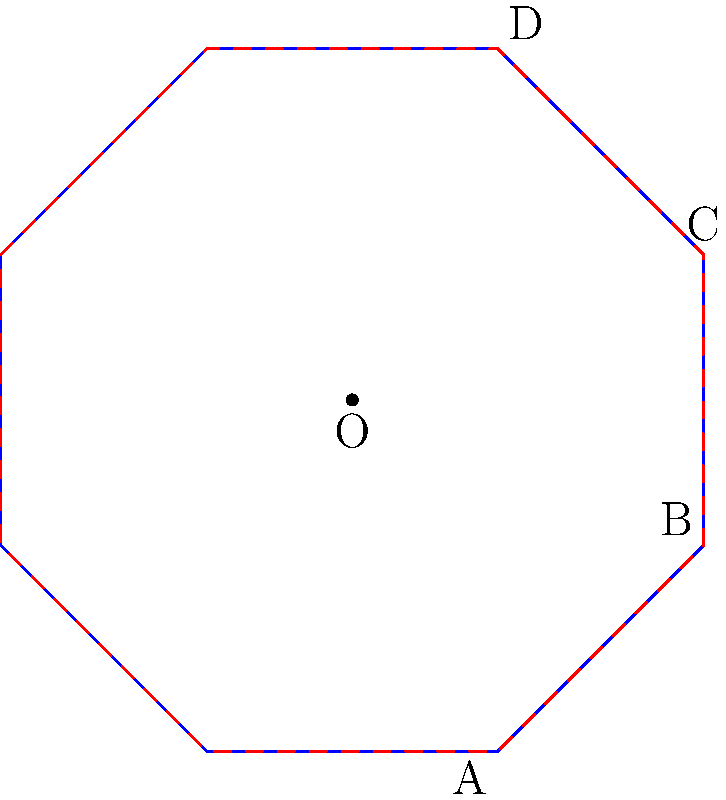The floor plan of an ancient octagonal temple is shown in blue. If the temple is rotated 45 degrees clockwise around its center O, which point will coincide with the position of point C in the original floor plan? To solve this problem, we need to understand the concept of rotational symmetry in regular polygons. Let's break it down step-by-step:

1. The blue octagon represents the original floor plan of the temple.
2. The red dashed octagon shows the result of a 45-degree clockwise rotation.
3. In a regular octagon, there are 8 sides, and each internal angle is 135 degrees.
4. A 45-degree rotation is equivalent to moving 1/8 of the way around the octagon.
5. When rotating clockwise, we need to count 1 vertex in the clockwise direction from each point.
6. Point C is located at the top of the original octagon.
7. To find which point will coincide with C after rotation, we need to move one vertex counter-clockwise from C in the original octagon.
8. Moving one vertex counter-clockwise from C, we arrive at point B.

Therefore, after a 45-degree clockwise rotation, point B will coincide with the original position of point C.

This problem demonstrates how understanding geometric principles can help interpret architectural designs in religious structures, bridging the gap between theological studies and scientific reasoning.
Answer: B 